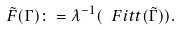<formula> <loc_0><loc_0><loc_500><loc_500>\tilde { F } ( \Gamma ) \colon = \lambda ^ { - 1 } ( \ F i t t ( \tilde { \Gamma } ) ) .</formula> 